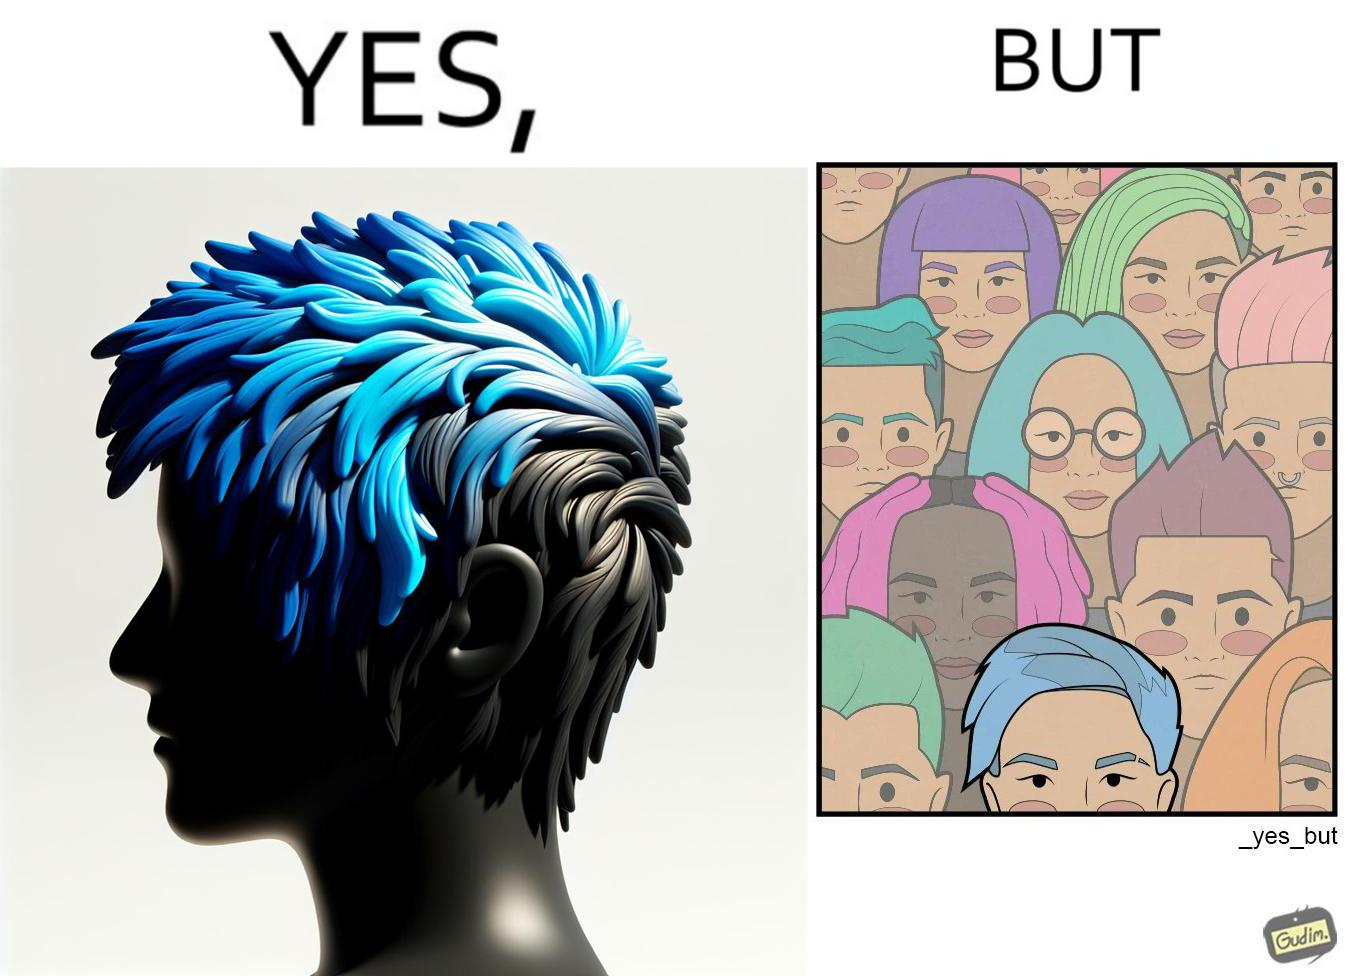Why is this image considered satirical? The image is funny, as one person with a hair dyed blue seems to symbolize that the person is going against the grain, however, when we zoom out, the group of people have hair dyed in several, different colors, showing that, dyeing hair is the new normal. 